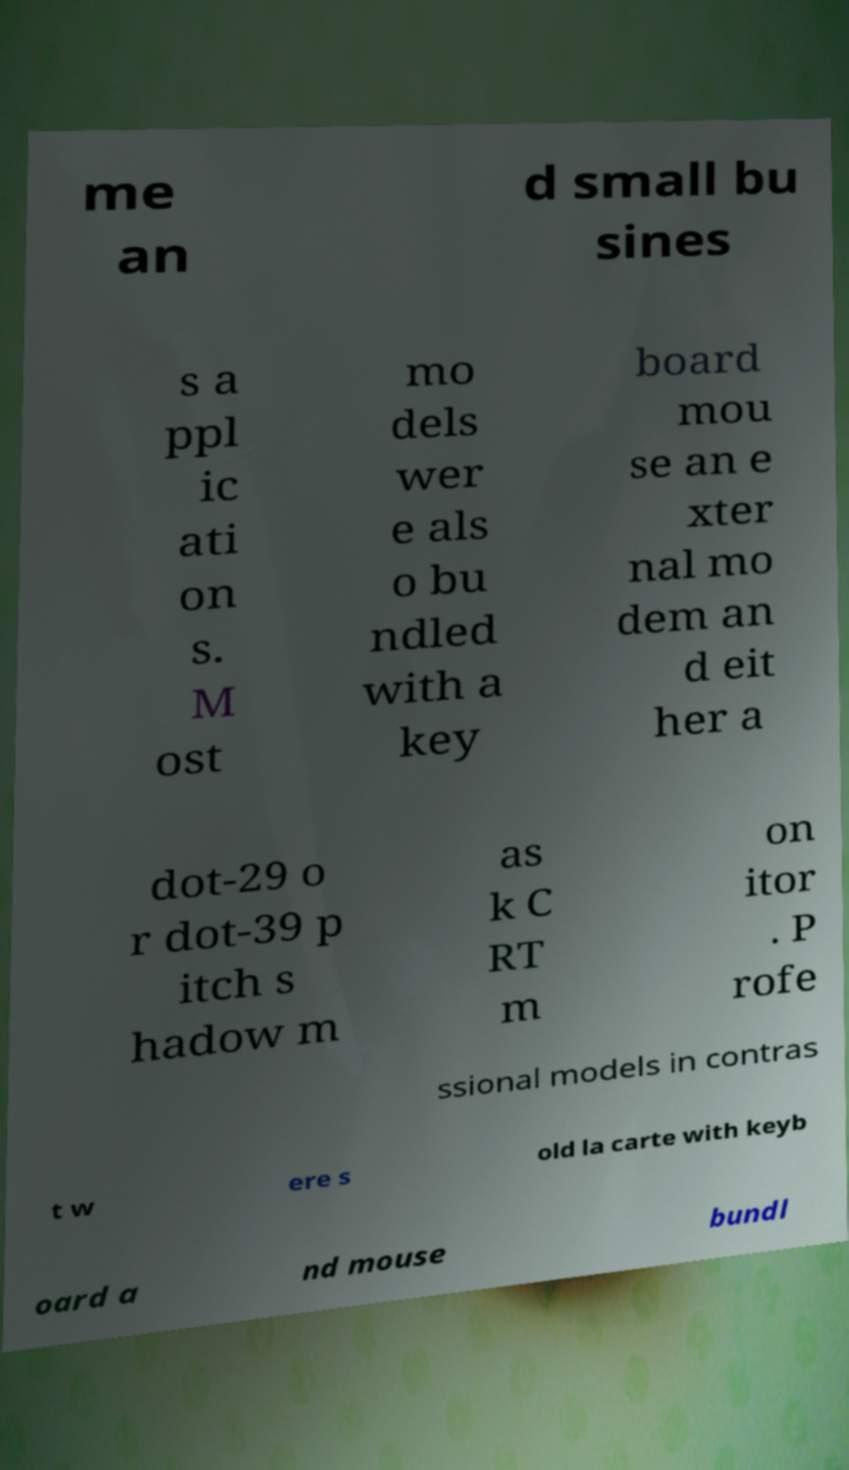What messages or text are displayed in this image? I need them in a readable, typed format. me an d small bu sines s a ppl ic ati on s. M ost mo dels wer e als o bu ndled with a key board mou se an e xter nal mo dem an d eit her a dot-29 o r dot-39 p itch s hadow m as k C RT m on itor . P rofe ssional models in contras t w ere s old la carte with keyb oard a nd mouse bundl 